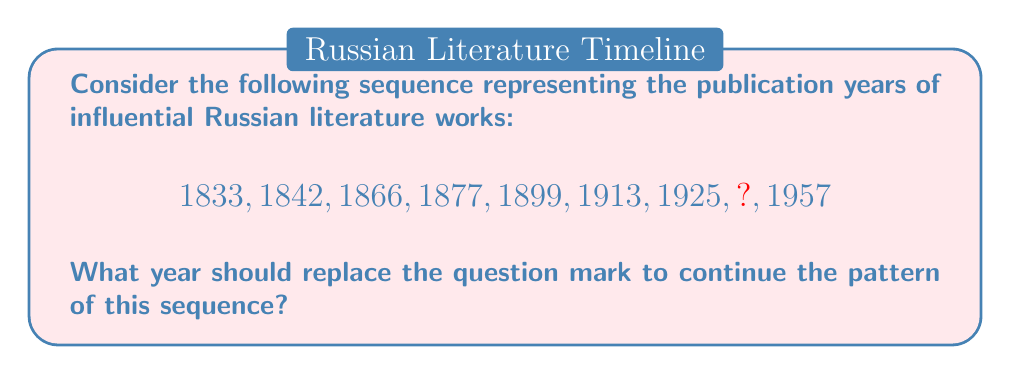Solve this math problem. To solve this problem, let's analyze the pattern in the given sequence:

1. Calculate the differences between consecutive terms:
   $1842 - 1833 = 9$
   $1866 - 1842 = 24$
   $1877 - 1866 = 11$
   $1899 - 1877 = 22$
   $1913 - 1899 = 14$
   $1925 - 1913 = 12$
   $1957 - ? = ?$

2. Observe that the differences alternate between increasing and decreasing:
   $9, 24, 11, 22, 14, 12, ?, ?$

3. The pattern of differences follows this sequence:
   $9 + 15 = 24$
   $24 - 13 = 11$
   $11 + 11 = 22$
   $22 - 8 = 14$
   $14 - 2 = 12$

4. Following this pattern, the next difference should be:
   $12 + 6 = 18$

5. Therefore, the missing year can be calculated as:
   $1925 + 18 = 1943$

6. Verify: $1957 - 1943 = 14$, which fits the decreasing pattern.

Thus, the year 1943 should replace the question mark in the sequence.
Answer: 1943 